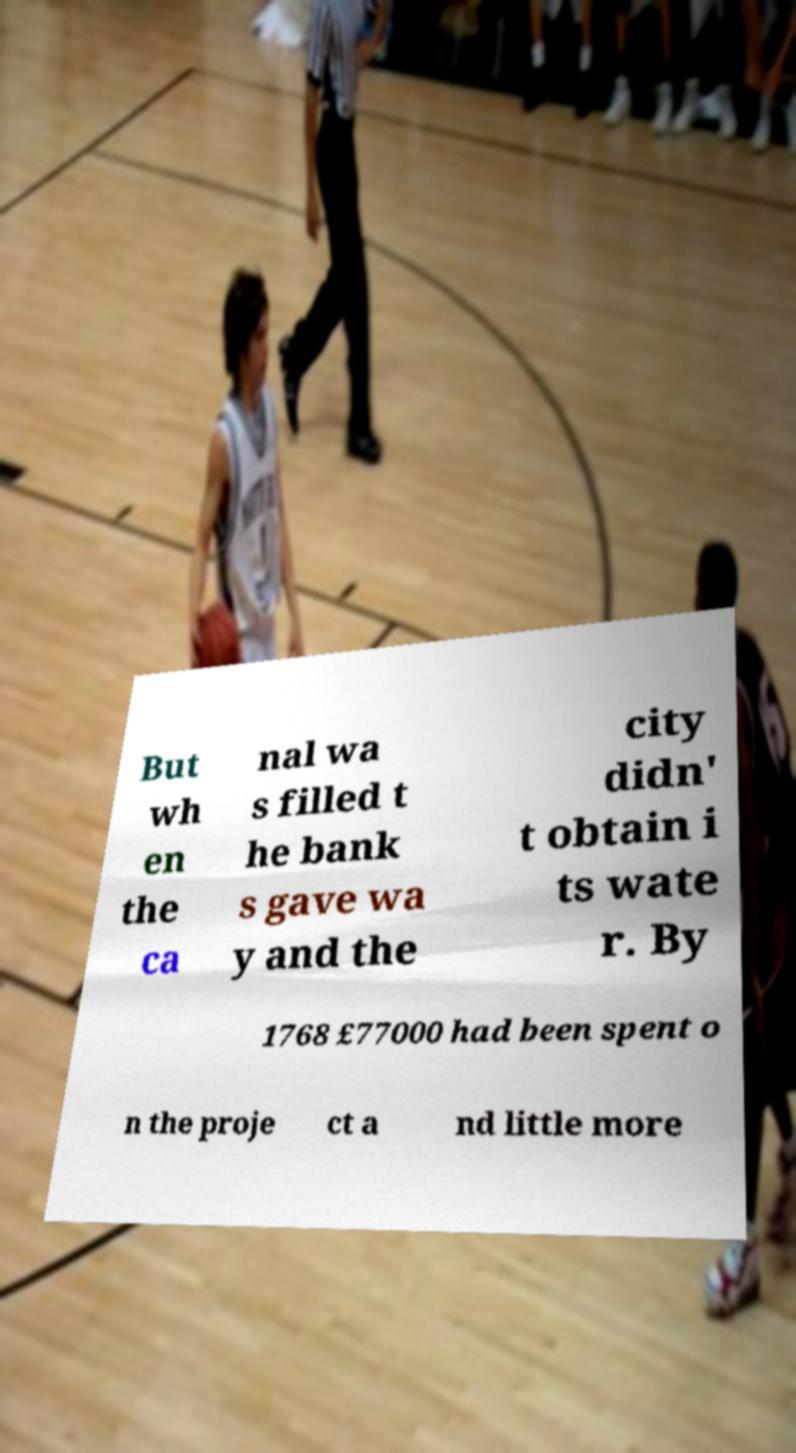There's text embedded in this image that I need extracted. Can you transcribe it verbatim? But wh en the ca nal wa s filled t he bank s gave wa y and the city didn' t obtain i ts wate r. By 1768 £77000 had been spent o n the proje ct a nd little more 